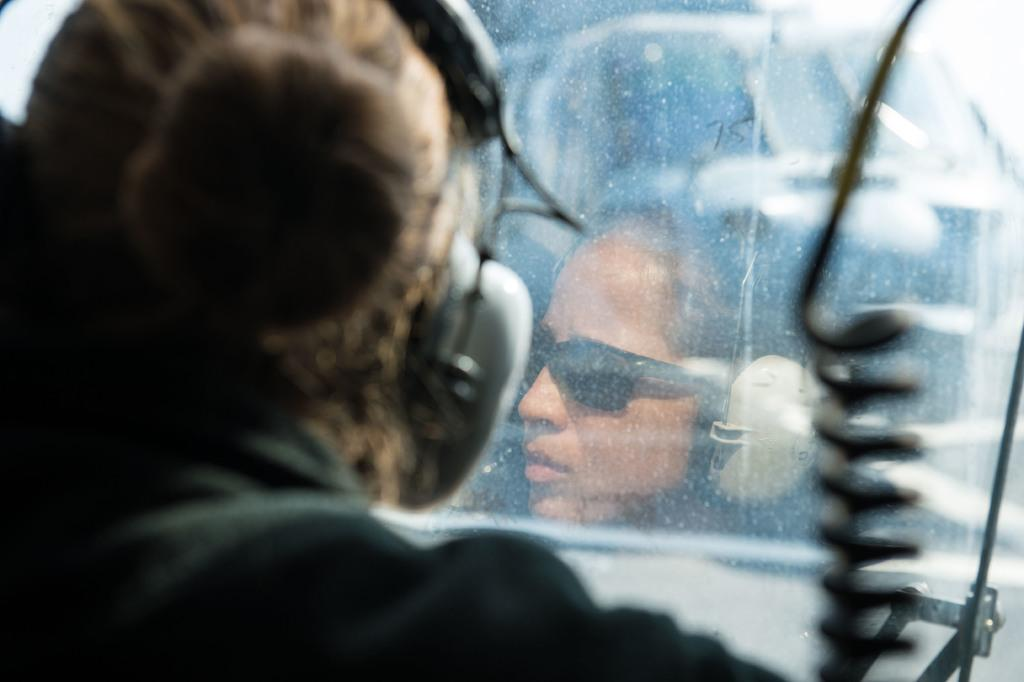What can be seen in the image? There is a person in the image. What is the person wearing? The person is wearing headphones. What is on the right side of the image? There are objects on the right side of the image. Can you describe the glass in the image? There is a glass with a reflection of the person in the image. Can you see a giraffe in the image? No, there is no giraffe present in the image. What type of roll is being used by the person in the image? There is no roll visible in the image; the person is wearing headphones. 